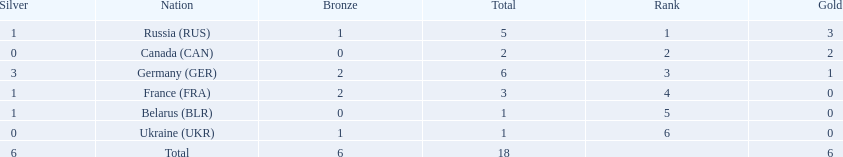Which countries competed in the 1995 biathlon? Russia (RUS), Canada (CAN), Germany (GER), France (FRA), Belarus (BLR), Ukraine (UKR). How many medals in total did they win? 5, 2, 6, 3, 1, 1. And which country had the most? Germany (GER). 